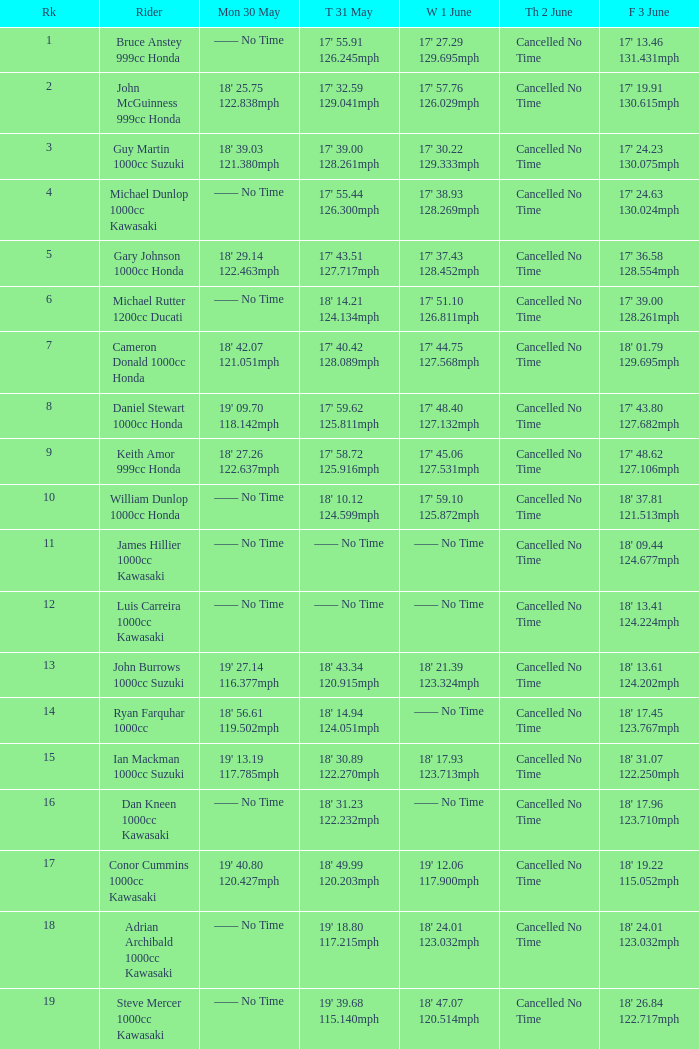What is the Thurs 2 June time for the rider with a Fri 3 June time of 17' 36.58 128.554mph? Cancelled No Time. 